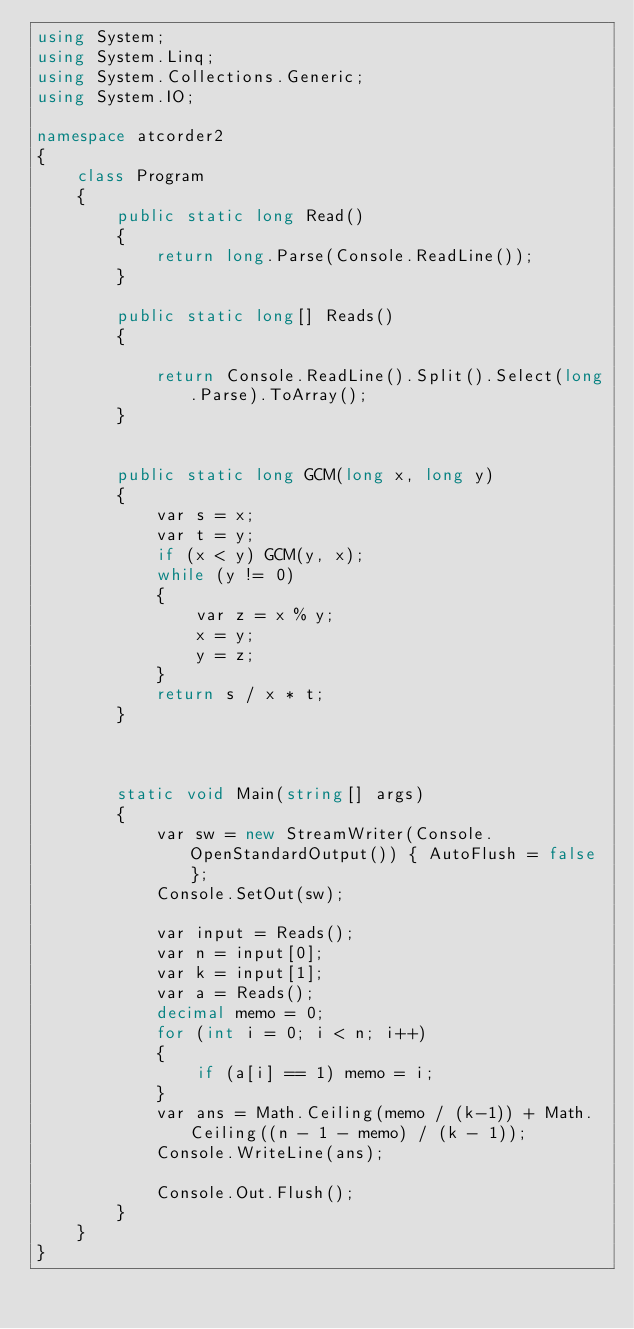<code> <loc_0><loc_0><loc_500><loc_500><_C#_>using System;
using System.Linq;
using System.Collections.Generic;
using System.IO;

namespace atcorder2
{
    class Program
    {
        public static long Read()
        {
            return long.Parse(Console.ReadLine());
        }

        public static long[] Reads()
        {

            return Console.ReadLine().Split().Select(long.Parse).ToArray();
        }


        public static long GCM(long x, long y)
        {
            var s = x;
            var t = y;
            if (x < y) GCM(y, x);
            while (y != 0)
            {
                var z = x % y;
                x = y;
                y = z;
            }
            return s / x * t;
        }



        static void Main(string[] args)
        {
            var sw = new StreamWriter(Console.OpenStandardOutput()) { AutoFlush = false };
            Console.SetOut(sw);

            var input = Reads();
            var n = input[0];
            var k = input[1];
            var a = Reads();
            decimal memo = 0;
            for (int i = 0; i < n; i++)
            {
                if (a[i] == 1) memo = i;
            }
            var ans = Math.Ceiling(memo / (k-1)) + Math.Ceiling((n - 1 - memo) / (k - 1));
            Console.WriteLine(ans);

            Console.Out.Flush();
        }
    }
}


</code> 